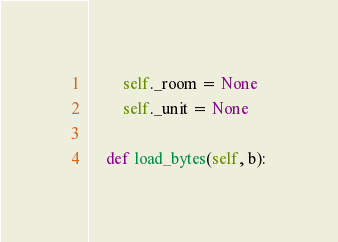Convert code to text. <code><loc_0><loc_0><loc_500><loc_500><_Python_>        self._room = None
        self._unit = None

    def load_bytes(self, b):</code> 